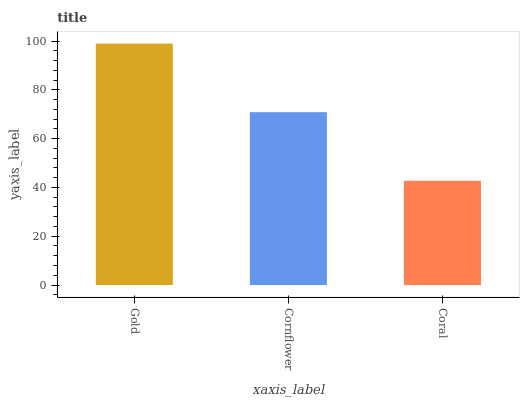Is Coral the minimum?
Answer yes or no. Yes. Is Gold the maximum?
Answer yes or no. Yes. Is Cornflower the minimum?
Answer yes or no. No. Is Cornflower the maximum?
Answer yes or no. No. Is Gold greater than Cornflower?
Answer yes or no. Yes. Is Cornflower less than Gold?
Answer yes or no. Yes. Is Cornflower greater than Gold?
Answer yes or no. No. Is Gold less than Cornflower?
Answer yes or no. No. Is Cornflower the high median?
Answer yes or no. Yes. Is Cornflower the low median?
Answer yes or no. Yes. Is Coral the high median?
Answer yes or no. No. Is Coral the low median?
Answer yes or no. No. 